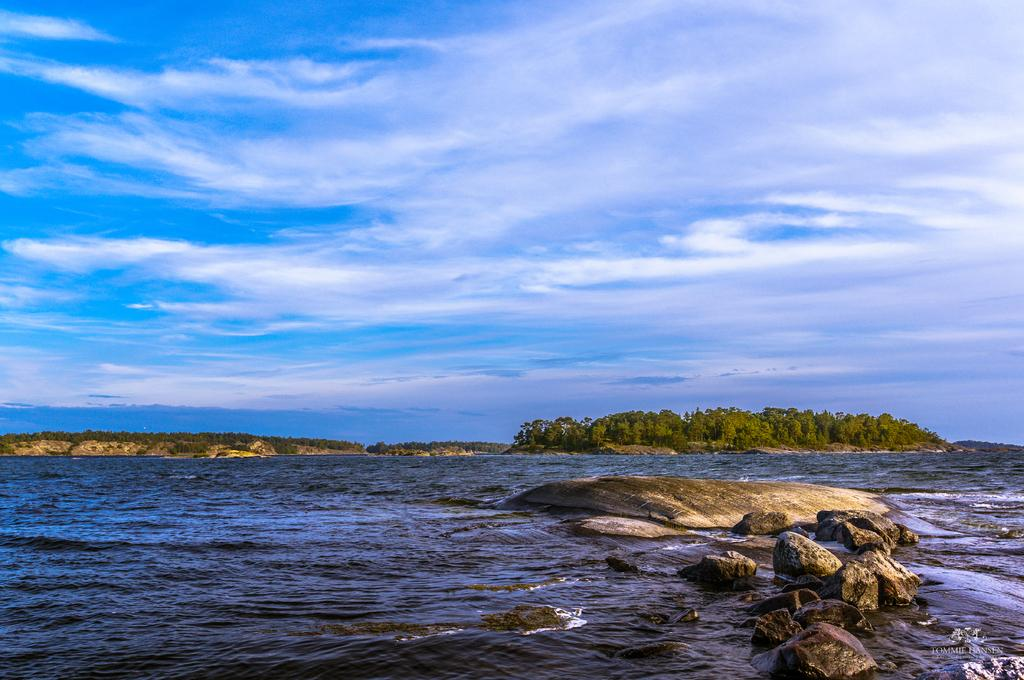Where was the image taken? The image was clicked outside the city. What can be seen in the foreground of the image? There is a water body and rocks in the foreground of the image. What is visible in the background of the image? There is a sky and trees visible in the background of the image. Can you see a monkey swinging from the trees in the image? No, there is no monkey present in the image. Is there a ray swimming in the water body in the image? No, there is no ray visible in the image. 